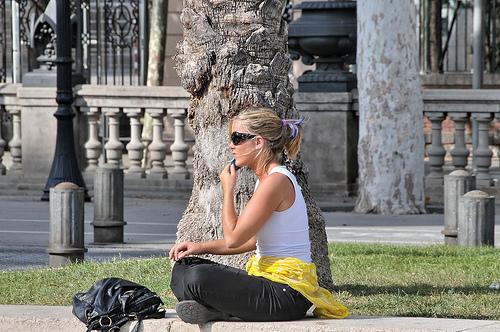Is this picture in color?
Keep it brief. Yes. Which hand holds the phone?
Short answer required. Left. What hairstyle is the woman wearing?
Give a very brief answer. Ponytail. What is cast?
Concise answer only. Shadow. What color is her purse?
Concise answer only. Black. What is this girl doing?
Write a very short answer. Talking on phone. 